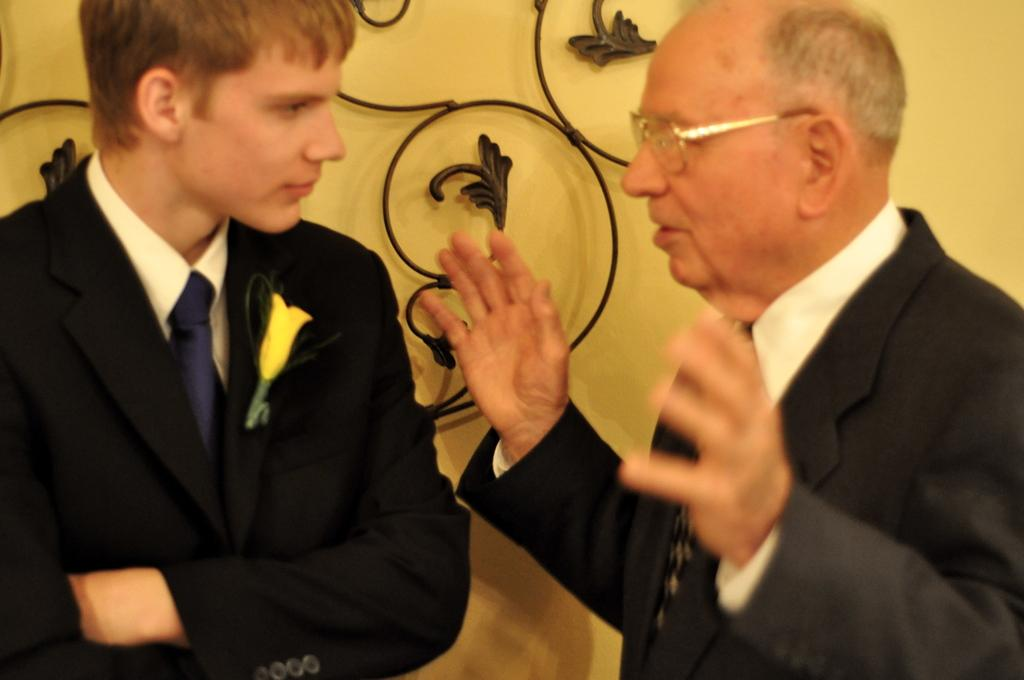How many people are in the image? There are two men in the image. Can you describe the appearance of one of the men? The man on the right side is wearing spectacles. What type of wax is being used for writing in the image? There is no wax or writing present in the image. What is the earth doing in the image? There is no reference to the earth or any planetary bodies in the image. 